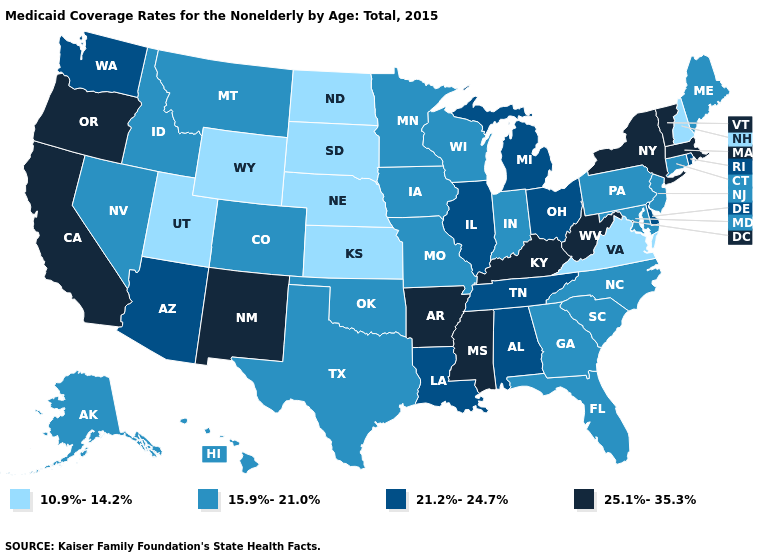Does the first symbol in the legend represent the smallest category?
Keep it brief. Yes. Among the states that border Virginia , which have the lowest value?
Give a very brief answer. Maryland, North Carolina. Does North Dakota have the highest value in the USA?
Be succinct. No. Name the states that have a value in the range 25.1%-35.3%?
Answer briefly. Arkansas, California, Kentucky, Massachusetts, Mississippi, New Mexico, New York, Oregon, Vermont, West Virginia. What is the value of South Carolina?
Keep it brief. 15.9%-21.0%. Among the states that border Indiana , does Ohio have the highest value?
Keep it brief. No. Does South Carolina have a higher value than Wyoming?
Quick response, please. Yes. What is the value of South Dakota?
Quick response, please. 10.9%-14.2%. Name the states that have a value in the range 10.9%-14.2%?
Give a very brief answer. Kansas, Nebraska, New Hampshire, North Dakota, South Dakota, Utah, Virginia, Wyoming. What is the value of Oregon?
Short answer required. 25.1%-35.3%. Does Michigan have the highest value in the MidWest?
Quick response, please. Yes. Which states have the lowest value in the West?
Be succinct. Utah, Wyoming. Which states have the lowest value in the USA?
Short answer required. Kansas, Nebraska, New Hampshire, North Dakota, South Dakota, Utah, Virginia, Wyoming. Among the states that border Montana , which have the highest value?
Give a very brief answer. Idaho. What is the value of South Carolina?
Write a very short answer. 15.9%-21.0%. 